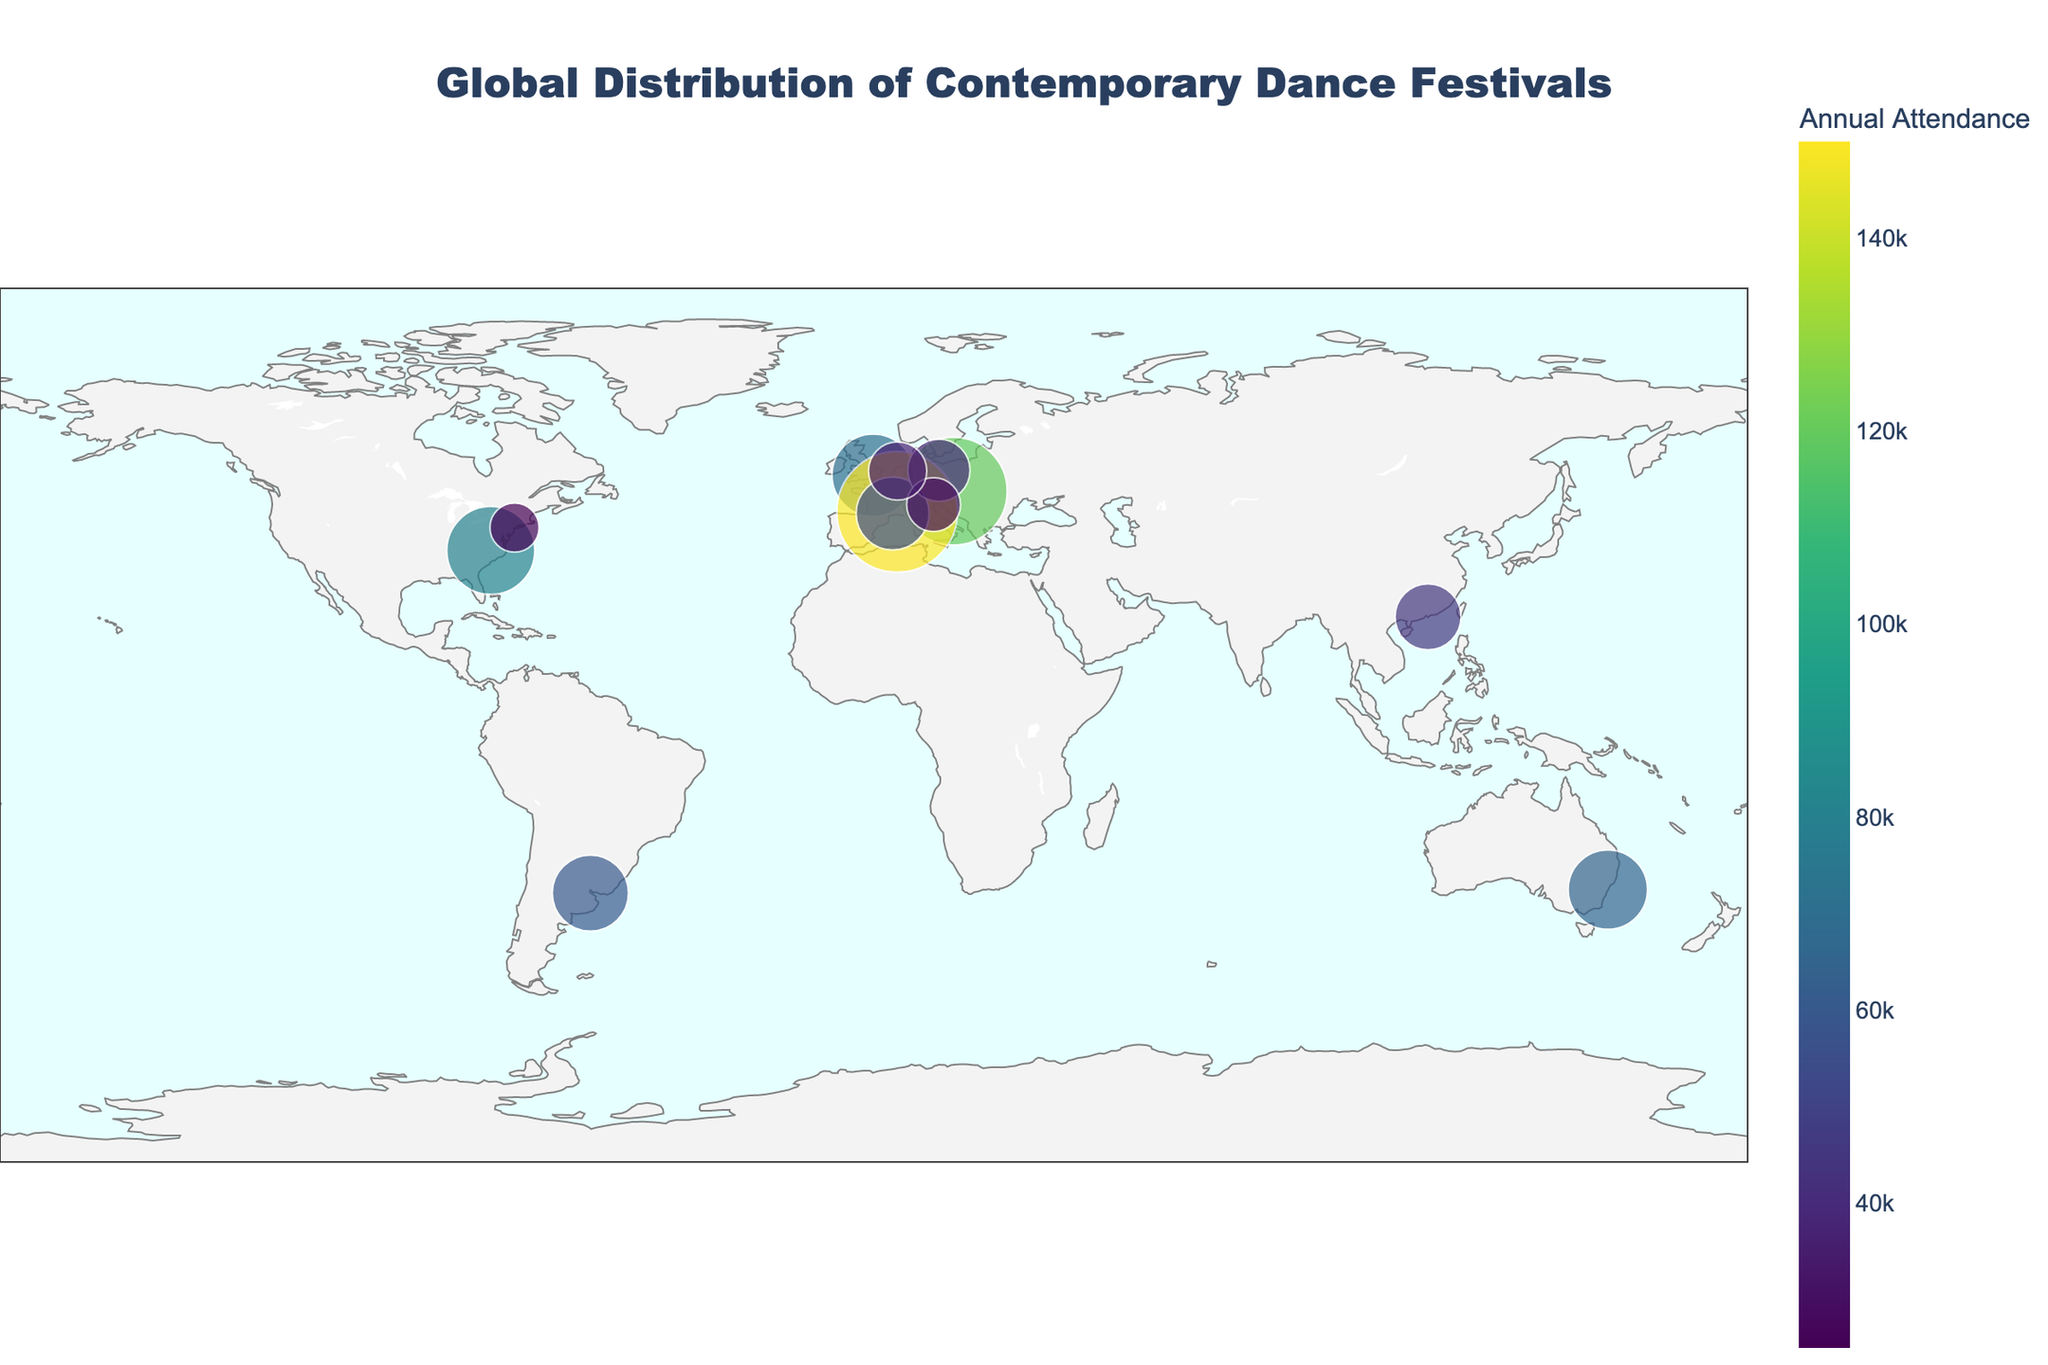What is the title of the figure? The title of the figure is displayed prominently at the top. By reading it, you'll see that the title is "Global Distribution of Contemporary Dance Festivals."
Answer: Global Distribution of Contemporary Dance Festivals Which dance festival has the highest annual attendance? The size and color of the dots represent the annual attendance rates. The largest and darkest dot corresponds to the Festival d'Avignon in France.
Answer: Festival d'Avignon How many dance festivals are located in Europe? By counting the number of annotated points within the geographical boundaries of Europe, you can see that there are six festivals: ImPulsTanz (Vienna), Dance Umbrella (London), Festival d'Avignon (Avignon), Montpellier Danse (Montpellier), Tanz im August (Berlin), and Dance Biennale (Venice).
Answer: 6 What is the approximate latitude and longitude of the Hong Kong International Choreography Festival? By referring to the location of the Hong Kong International Choreography Festival on the map and checking its annotation, the coordinates are approximately (22.3193, 114.1694).
Answer: (22.3193, 114.1694) Which festival has the smallest annual attendance? The smallest dot on the map with the lightest color represents the Fall for Dance festival in New York City.
Answer: Fall for Dance How does the annual attendance of Dance Umbrella in London compare to that of Tanz im August in Berlin? By comparing the sizes and colors of the dots for each festival, you can see that Dance Umbrella in London has a larger size and darker color, indicating a higher attendance rate of 70,000 compared to Tanz im August's 40,000.
Answer: Dance Umbrella has a higher attendance than Tanz im August What is the average annual attendance of the festivals located in France? Calculate the average of the attendance rates of the Festival d'Avignon (150,000) and Montpellier Danse (55,000). Sum these (150,000 + 55,000 = 205,000) and then divide by the number of festivals (2). 205,000 / 2 = 102,500.
Answer: 102,500 Which continents have the highest representation of contemporary dance festivals? By observing the geographic distribution, Europe clearly has the highest number of festivals (six in total). Other continents like North America and Asia have fewer festivals.
Answer: Europe Is there a correlation between the size/color of the dots and their geographic placement? The size and color of the dots represent the annual attendance, and the geographic placement shows there is no specific correlation seen between the size/color of the festivals and their placement on the map.
Answer: No specific correlation How does the attendance of the American Dance Festival in Durham compare to the Sydney Festival in Australia? By comparing the respective dot sizes and colors, the American Dance Festival in Durham has an attendance of 80,000, which is higher than the Sydney Festival's 65,000.
Answer: American Dance Festival has a higher attendance than Sydney Festival 